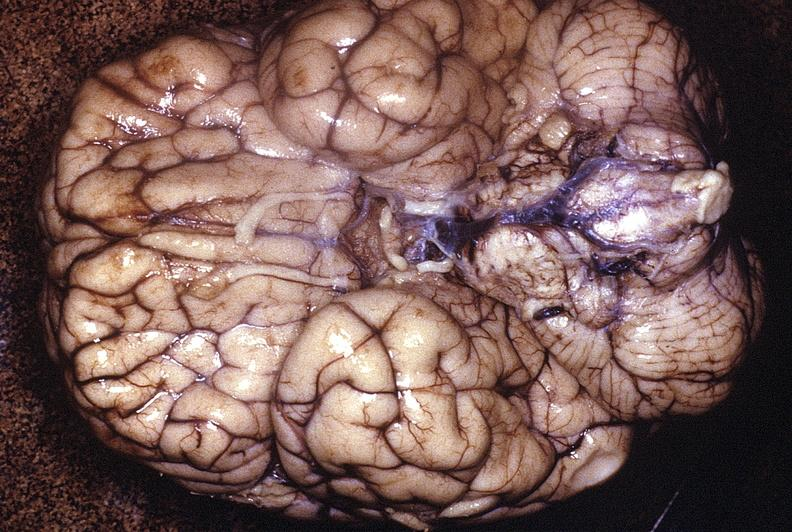does this image show normal brain?
Answer the question using a single word or phrase. Yes 